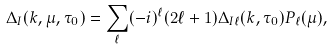Convert formula to latex. <formula><loc_0><loc_0><loc_500><loc_500>\Delta _ { I } ( k , \mu , \tau _ { 0 } ) = \sum _ { \ell } ( - i ) ^ { \ell } ( 2 \ell + 1 ) \Delta _ { I \ell } ( k , \tau _ { 0 } ) P _ { \ell } ( \mu ) ,</formula> 